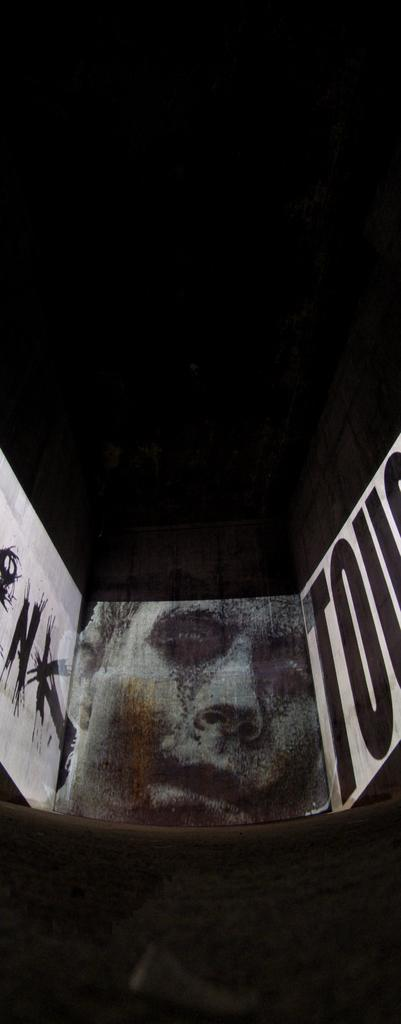What is on the wall in the image? There is a picture and text on the wall in the image. Can you describe the picture on the wall? Unfortunately, the provided facts do not give any details about the picture on the wall. What does the text on the wall say? The provided facts do not give any information about the content of the text on the wall. How many teeth can be seen in the image? There are no teeth visible in the image. What is the memory capacity of the device in the image? There is no device present in the image, so it is not possible to determine its memory capacity. 